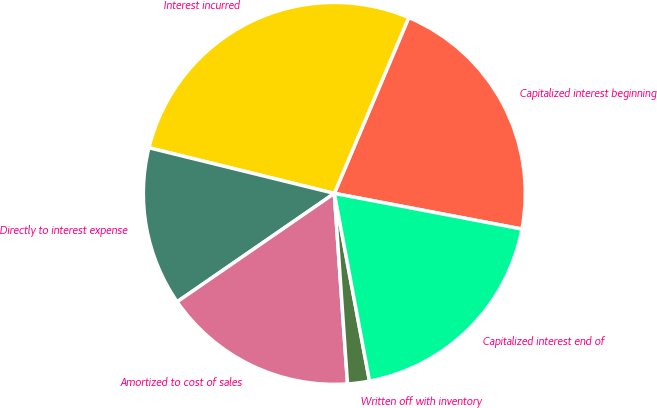Convert chart to OTSL. <chart><loc_0><loc_0><loc_500><loc_500><pie_chart><fcel>Capitalized interest beginning<fcel>Interest incurred<fcel>Directly to interest expense<fcel>Amortized to cost of sales<fcel>Written off with inventory<fcel>Capitalized interest end of<nl><fcel>21.62%<fcel>27.53%<fcel>13.45%<fcel>16.49%<fcel>1.85%<fcel>19.06%<nl></chart> 